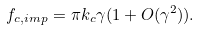<formula> <loc_0><loc_0><loc_500><loc_500>f _ { c , i m p } = \pi k _ { c } \gamma ( 1 + O ( \gamma ^ { 2 } ) ) .</formula> 